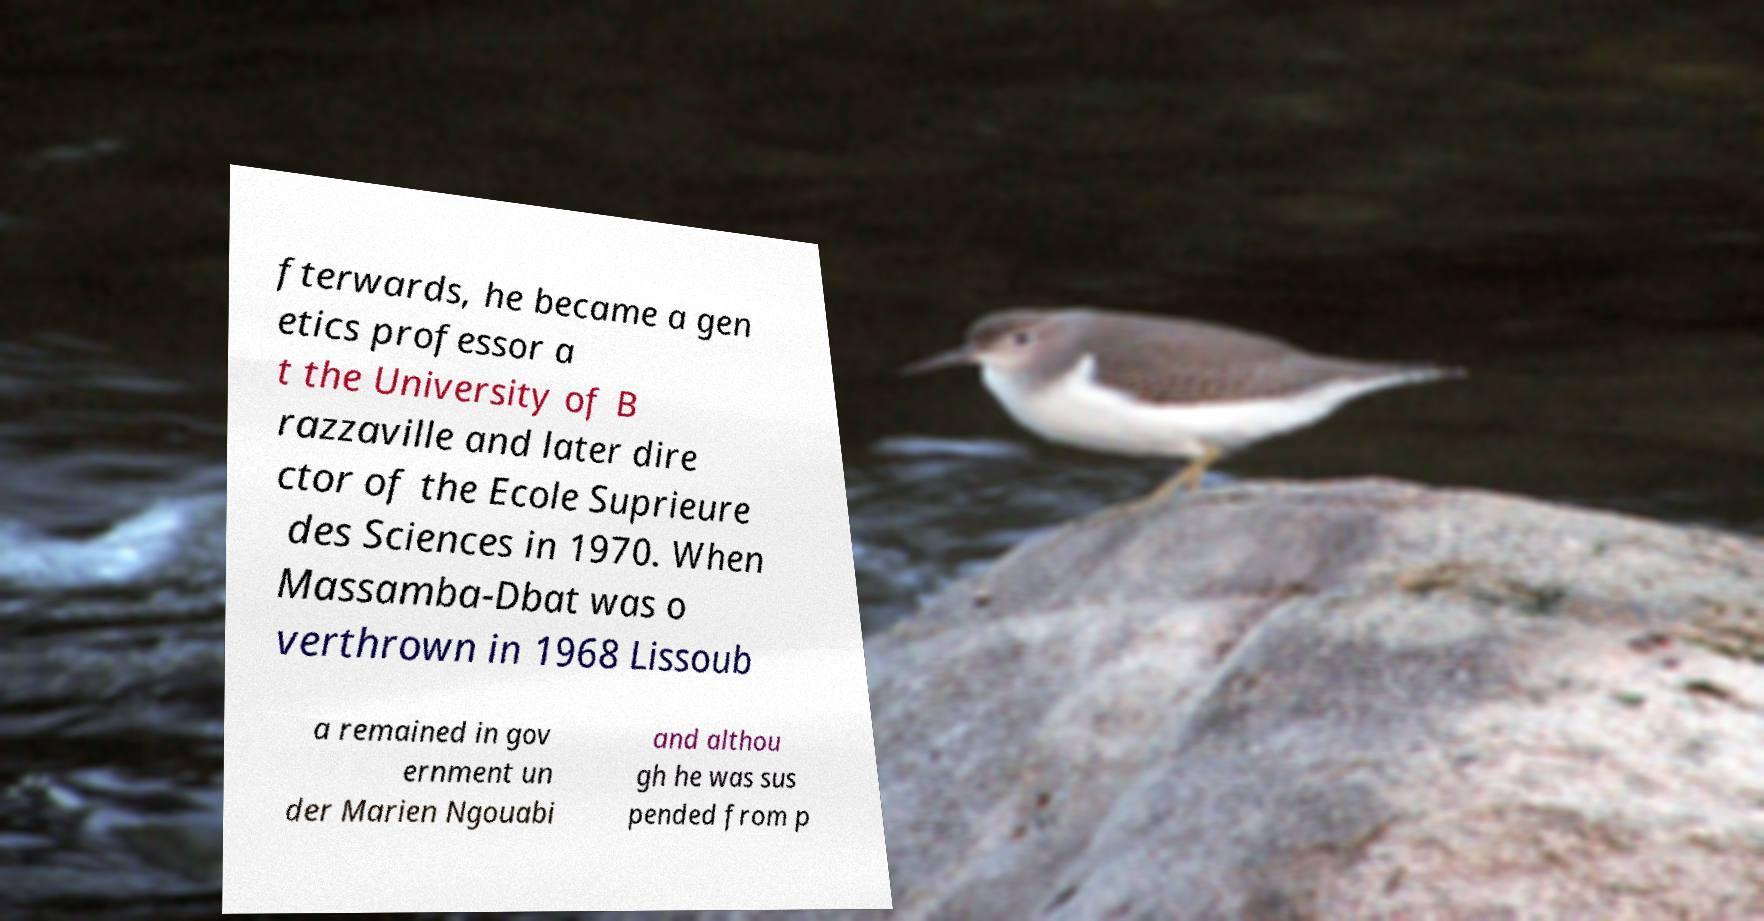Can you accurately transcribe the text from the provided image for me? fterwards, he became a gen etics professor a t the University of B razzaville and later dire ctor of the Ecole Suprieure des Sciences in 1970. When Massamba-Dbat was o verthrown in 1968 Lissoub a remained in gov ernment un der Marien Ngouabi and althou gh he was sus pended from p 